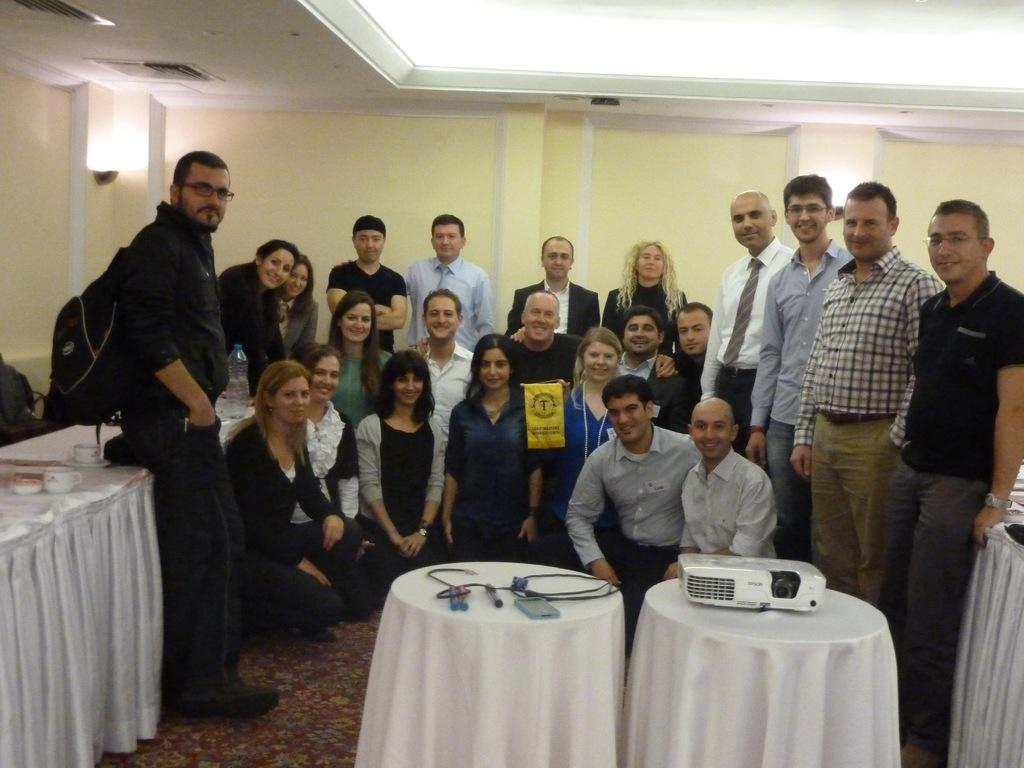What are the people in the image doing? There are persons standing and sitting in the image. What objects can be seen on the tables in the image? There is a bottle, a cap, a cable, a projector, and a cloth on the tables in the image. What is the floor like in the image? The floor is visible in the image. What can be seen in the background of the image? There is a wall in the background of the image. What type of ornament is hanging from the ceiling in the image? There is no ornament hanging from the ceiling in the image. How does the spring affect the people in the image? There is no mention of a spring in the image, so it cannot affect the people. 